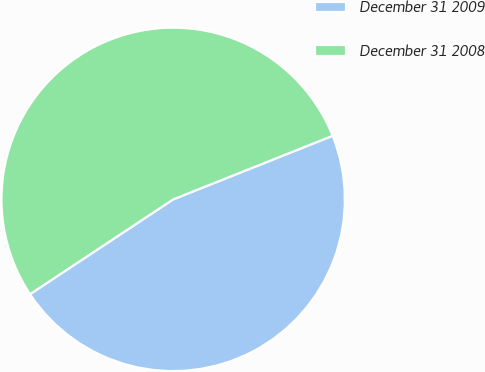Convert chart. <chart><loc_0><loc_0><loc_500><loc_500><pie_chart><fcel>December 31 2009<fcel>December 31 2008<nl><fcel>46.73%<fcel>53.27%<nl></chart> 